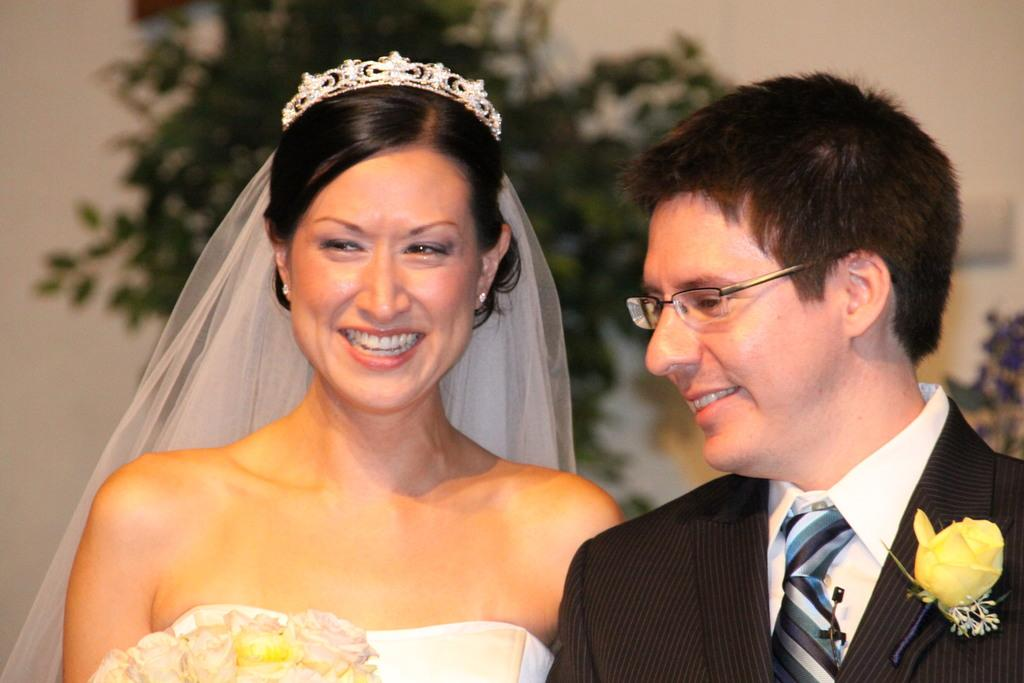How many people are in the image? There are two persons standing in the middle of the image. What are the persons doing in the image? The persons are smiling. What can be seen in the background of the image? There are plants and a wall visible in the background. What type of turkey can be seen in the image? There is no turkey present in the image. Is there a party happening in the image? The image does not provide any information about a party taking place. 